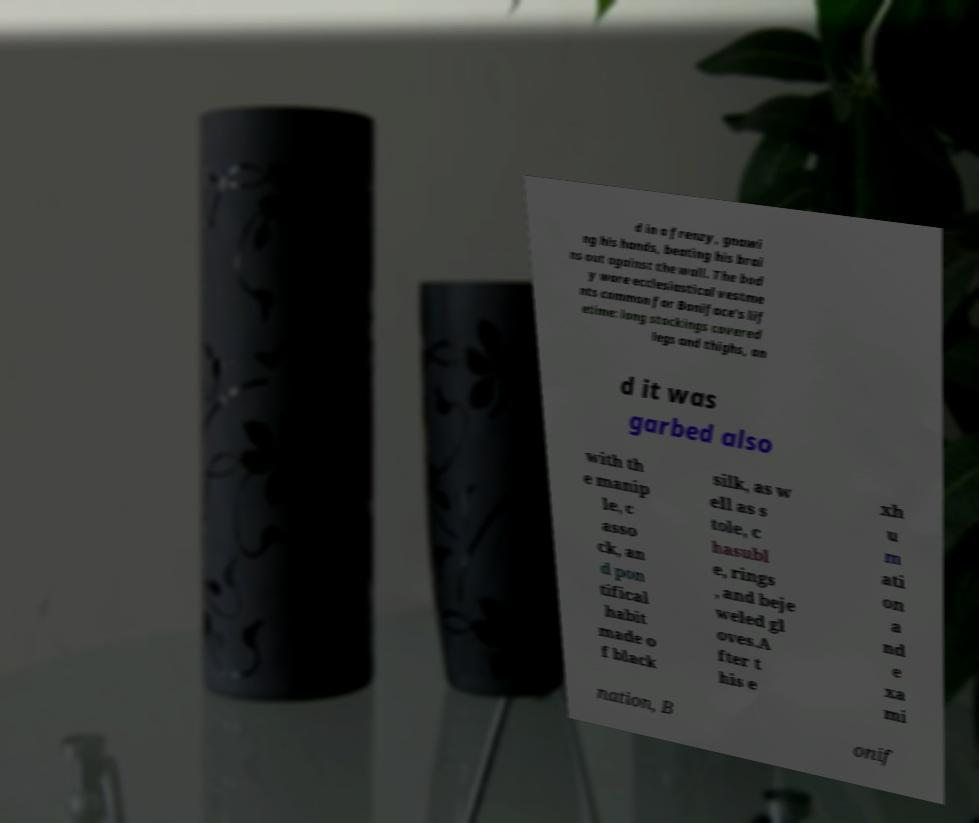There's text embedded in this image that I need extracted. Can you transcribe it verbatim? d in a frenzy, gnawi ng his hands, beating his brai ns out against the wall. The bod y wore ecclesiastical vestme nts common for Boniface's lif etime: long stockings covered legs and thighs, an d it was garbed also with th e manip le, c asso ck, an d pon tifical habit made o f black silk, as w ell as s tole, c hasubl e, rings , and beje weled gl oves.A fter t his e xh u m ati on a nd e xa mi nation, B onif 